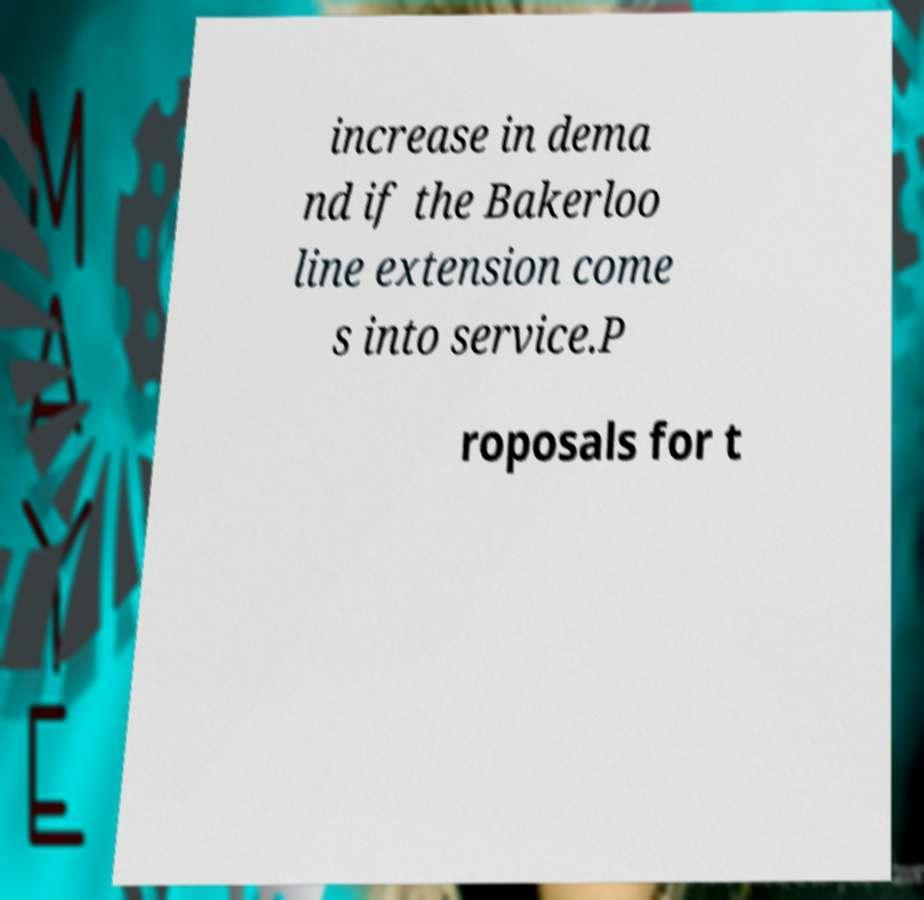Can you read and provide the text displayed in the image?This photo seems to have some interesting text. Can you extract and type it out for me? increase in dema nd if the Bakerloo line extension come s into service.P roposals for t 